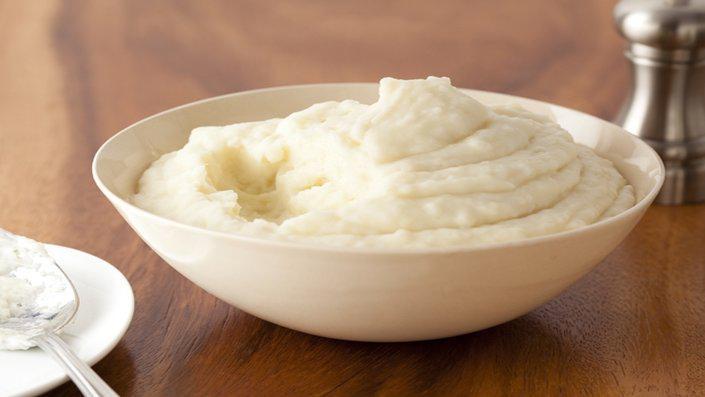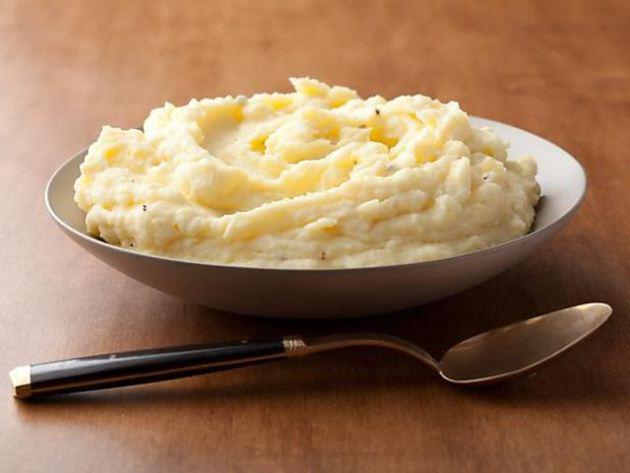The first image is the image on the left, the second image is the image on the right. Examine the images to the left and right. Is the description "At least one bowl is white." accurate? Answer yes or no. Yes. 